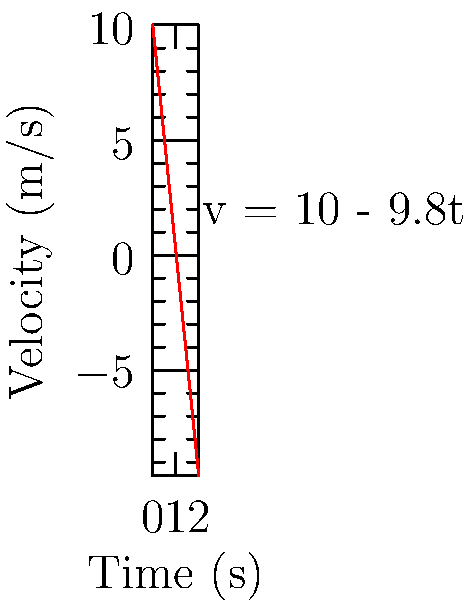As a PowerShell expert, you're developing a script to simulate falling objects. Given an object with an initial velocity of 10 m/s downward and a descent time of 2 seconds, calculate its acceleration. Use the velocity-time graph provided, where the equation is v = 10 - 9.8t. How would you structure a PowerShell function to compute this acceleration? To solve this problem and create a PowerShell function, we'll follow these steps:

1. Understand the given information:
   - Initial velocity (v₀) = 10 m/s (downward)
   - Time of descent (t) = 2 s
   - Velocity equation: v = 10 - 9.8t

2. Identify the acceleration formula:
   a = (v - v₀) / t, where v is the final velocity

3. Calculate the final velocity using the given equation:
   v = 10 - 9.8t
   v = 10 - 9.8(2)
   v = 10 - 19.6
   v = -9.6 m/s

4. Apply the acceleration formula:
   a = (v - v₀) / t
   a = (-9.6 - 10) / 2
   a = -19.6 / 2
   a = -9.8 m/s²

5. Create a PowerShell function to calculate the acceleration:

```powershell
function Calculate-Acceleration {
    param (
        [double]$initialVelocity,
        [double]$time
    )
    
    $finalVelocity = 10 - 9.8 * $time
    $acceleration = ($finalVelocity - $initialVelocity) / $time
    
    return $acceleration
}

$result = Calculate-Acceleration -initialVelocity 10 -time 2
Write-Output "The acceleration is $result m/s²"
```

This function takes the initial velocity and time as parameters, calculates the final velocity using the given equation, and then computes the acceleration using the formula a = (v - v₀) / t.
Answer: -9.8 m/s² 